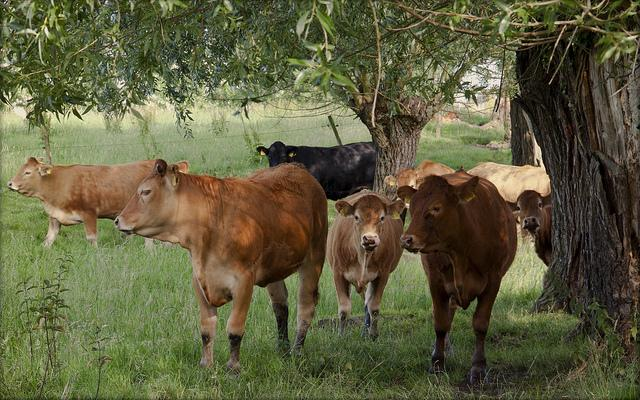What is the young offspring of these animals called? Please explain your reasoning. calf. The animals are cows, and most herd animals have the same name for their young. 